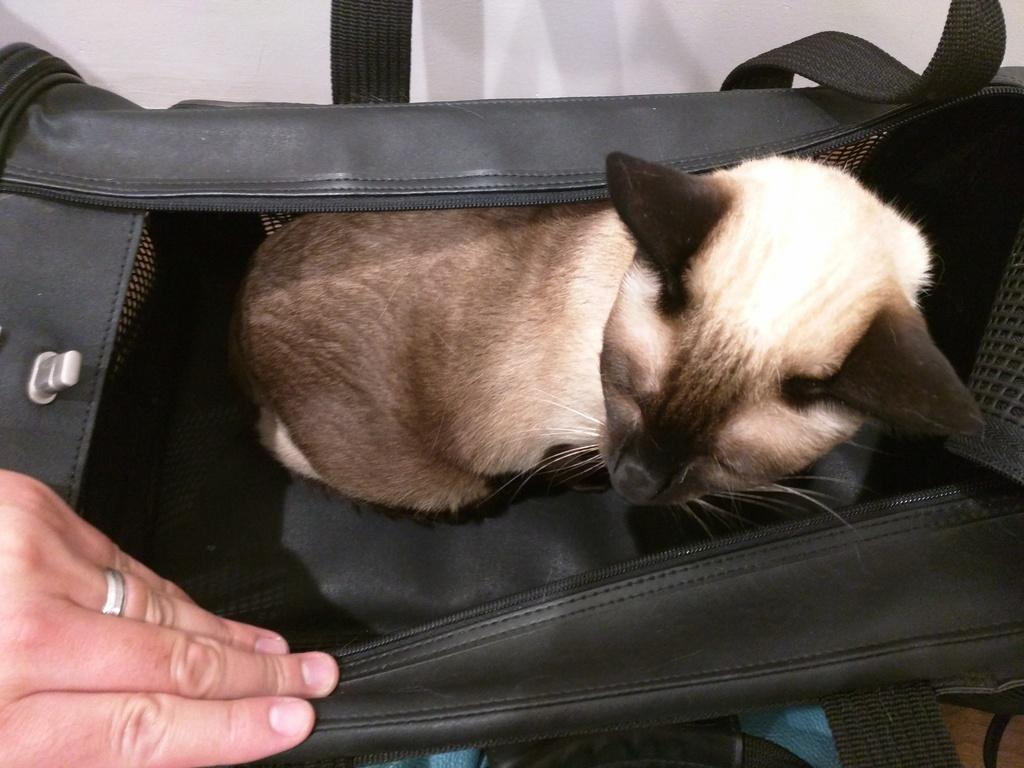What animal is present in the image? There is a cat in the image. Where is the cat located? The cat is in a bag. Can you see any part of a person in the image? Yes, there is a person's hand in the bottom left corner of the image. What color is the background of the image? The background of the image is white. What type of oven is visible in the image? There is no oven present in the image. What kind of lace can be seen on the cat's collar in the image? The cat is in a bag, and there is no collar visible in the image. 